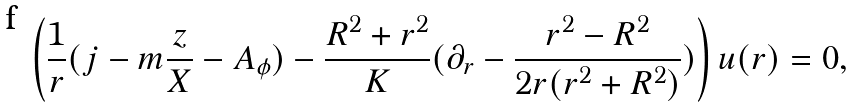<formula> <loc_0><loc_0><loc_500><loc_500>\left ( \frac { 1 } { r } ( j - m \frac { z } { X } - A _ { \phi } ) - \frac { R ^ { 2 } + r ^ { 2 } } { K } ( \partial _ { r } - \frac { r ^ { 2 } - R ^ { 2 } } { 2 r ( r ^ { 2 } + R ^ { 2 } ) } ) \right ) u ( r ) = 0 ,</formula> 